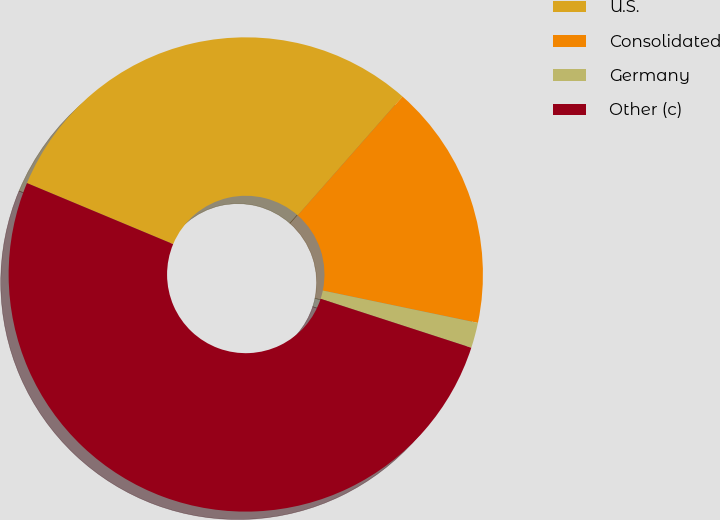<chart> <loc_0><loc_0><loc_500><loc_500><pie_chart><fcel>U.S.<fcel>Consolidated<fcel>Germany<fcel>Other (c)<nl><fcel>30.2%<fcel>16.78%<fcel>1.73%<fcel>51.3%<nl></chart> 